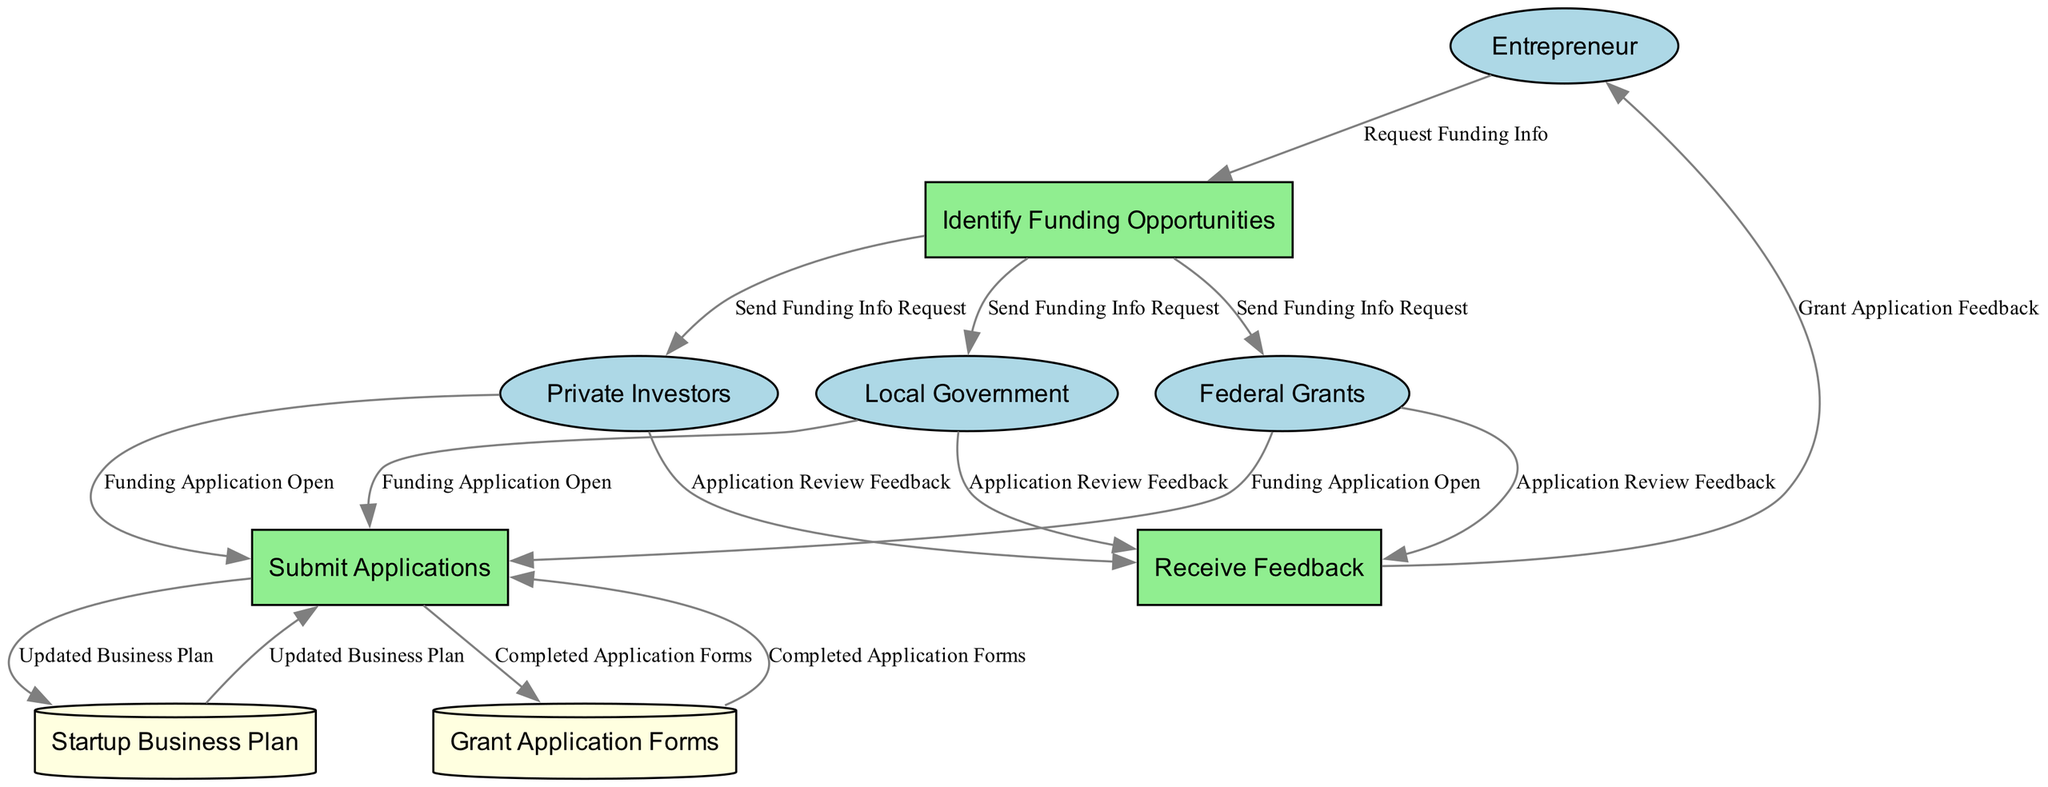What are the external entities in this diagram? The external entities listed in the diagram are: Entrepreneur, Local Government, Federal Grants, and Private Investors. These are the sources or receivers of information outside the system being described.
Answer: Entrepreneur, Local Government, Federal Grants, Private Investors How many data stores are present in the diagram? The diagram contains two data stores: Startup Business Plan and Grant Application Forms. Counting them gives us the total number of data stores.
Answer: 2 What is the output of the process "Identify Funding Opportunities"? The process "Identify Funding Opportunities" has three outputs: Local Government, Federal Grants, and Private Investors. These are the entities that receive the information after identification of funding opportunities.
Answer: Local Government, Federal Grants, Private Investors What triggers the "Submit Applications" process? The process "Submit Applications" is triggered by the inputs from three entities: Local Government, Federal Grants, and Private Investors, which indicate that a funding application is open. This means that these entities initiate the application process.
Answer: Funding Application Open How does the "Receive Feedback" process relate to the "Submit Applications" process? The "Receive Feedback" process takes inputs from the outputs of the "Submit Applications" process, specifically feedback from Local Government, Federal Grants, and Private Investors on application reviews. This shows the dependency of feedback on previously submitted applications.
Answer: Receives feedback from application reviews What is the first step an Entrepreneur must take to access funding opportunities? The first step is to request funding information by contacting the Identify Funding Opportunities process. This indicates that the entrepreneur initiates the process to gather options for funding.
Answer: Request Funding Info Which process leads to the generation of completed application forms? The process "Submit Applications" leads to the generation of completed application forms, which are directed towards Grant Application Forms and are filled out based on the inputs received.
Answer: Submit Applications How many feedback sources are there in the "Receive Feedback" process? There are three sources of feedback in the "Receive Feedback" process: Local Government, Federal Grants, and Private Investors. Counting these sources gives the total number of feedback providers.
Answer: 3 What happens to the Startup Business Plan during the submission of applications? During the submission of applications, there is an output labeled "Updated Business Plan," which indicates that the Startup Business Plan may be revised to meet application requirements before submission.
Answer: Updated Business Plan 